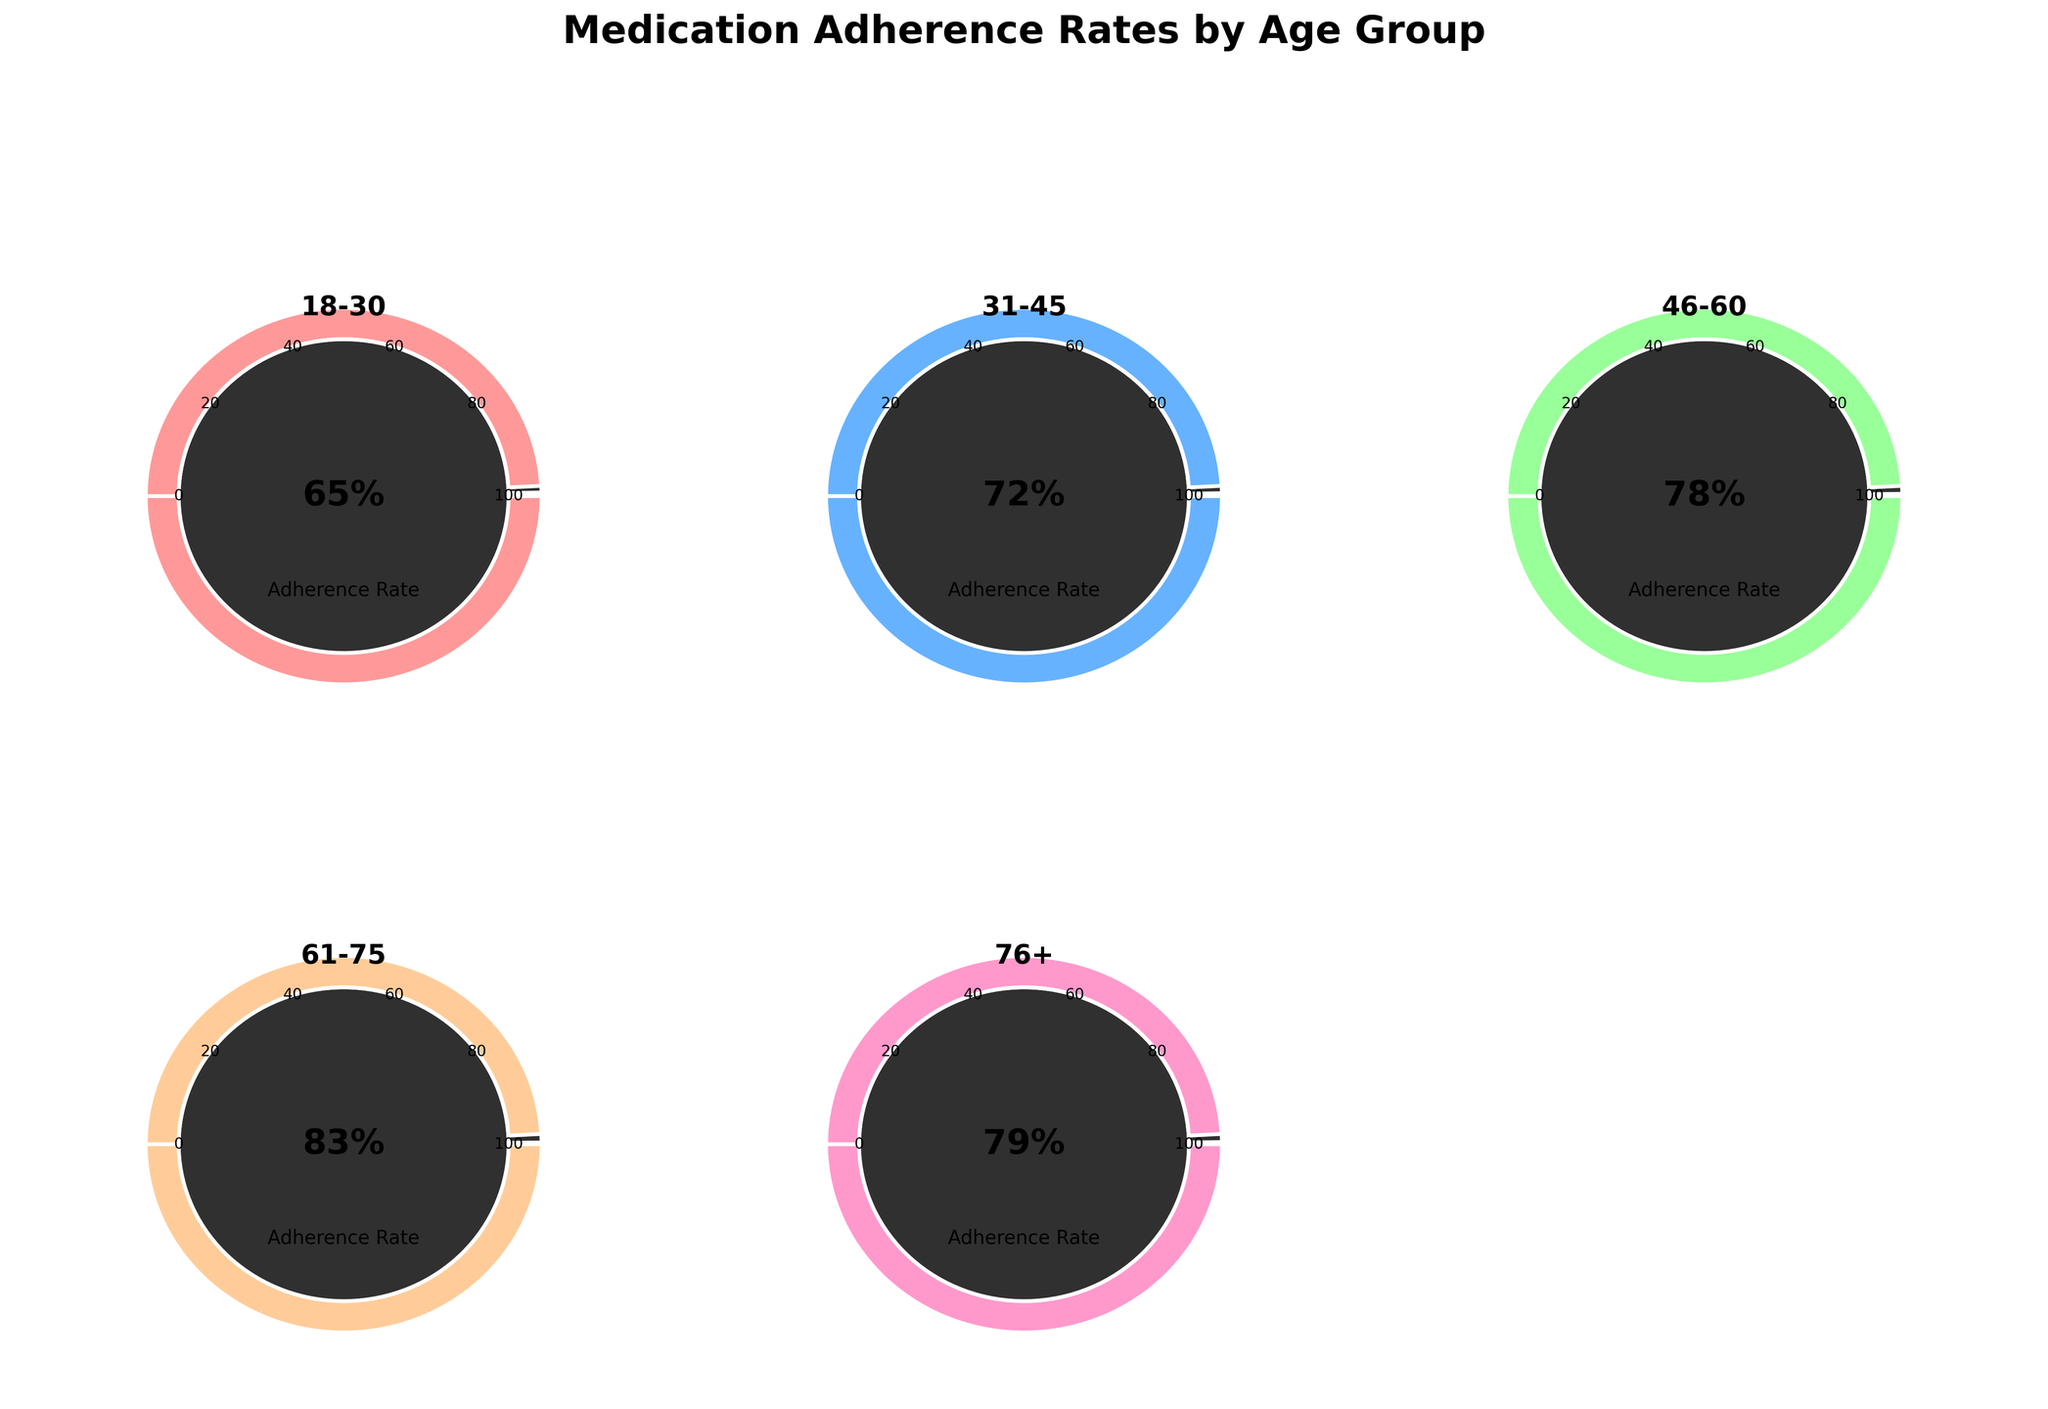What's the adherence rate for the age group 61-75? The adherence rate for the age group 61-75 can be found by looking at their specific gauge chart. According to the figure, the adherence rate for this group is 83%.
Answer: 83% Which age group has the lowest adherence rate? To determine the age group with the lowest adherence rate, compare all the adherence rates displayed in the gauge charts. The lowest adherence rate is 65%, which belongs to the age group 18-30.
Answer: 18-30 Which color represents the adherence rate for the age group 76+? Identify the age group 76+ in the chart and note the color used in the gauge. The gauge for age group 76+ is magenta-pink in color.
Answer: Magenta-pink What is the difference in adherence rates between the age groups 31-45 and 46-60? Find the adherence rates for both age groups (31-45 is 72%, 46-60 is 78%). Subtract the adherence rate of 31-45 from that of 46-60: 78% - 72% = 6%.
Answer: 6% How does the adherence rate for the age group 18-30 compare to the overall highest adherence rate? Identify the adherence rate for 18-30 (65%) and compare it to the highest adherence rate visible (83% for 61-75). The adherence rate for 18-30 is 18% lower than the highest rate.
Answer: 18% lower Calculate the average adherence rate across all age groups. Sum the adherence rates (65% + 72% + 78% + 83% + 79% = 377%) and divide by the number of age groups (5). The average rate is 377% / 5 = 75.4%.
Answer: 75.4% Which age groups have an adherence rate higher than 75%? Scan through the gauge charts to identify rates greater than 75%. The age groups 46-60 (78%), 61-75 (83%) and 76+ (79%) have rates higher than 75%.
Answer: 46-60, 61-75, 76+ What is the median adherence rate across all age groups? List the adherence rates in ascending order (65%, 72%, 78%, 79%, 83%). The median is the middle value, which is 78%.
Answer: 78% Are there any age groups with equal adherence rates? Review the adherence rates for all age groups. None of the age groups have equal adherence rates based on the figure provided.
Answer: No 